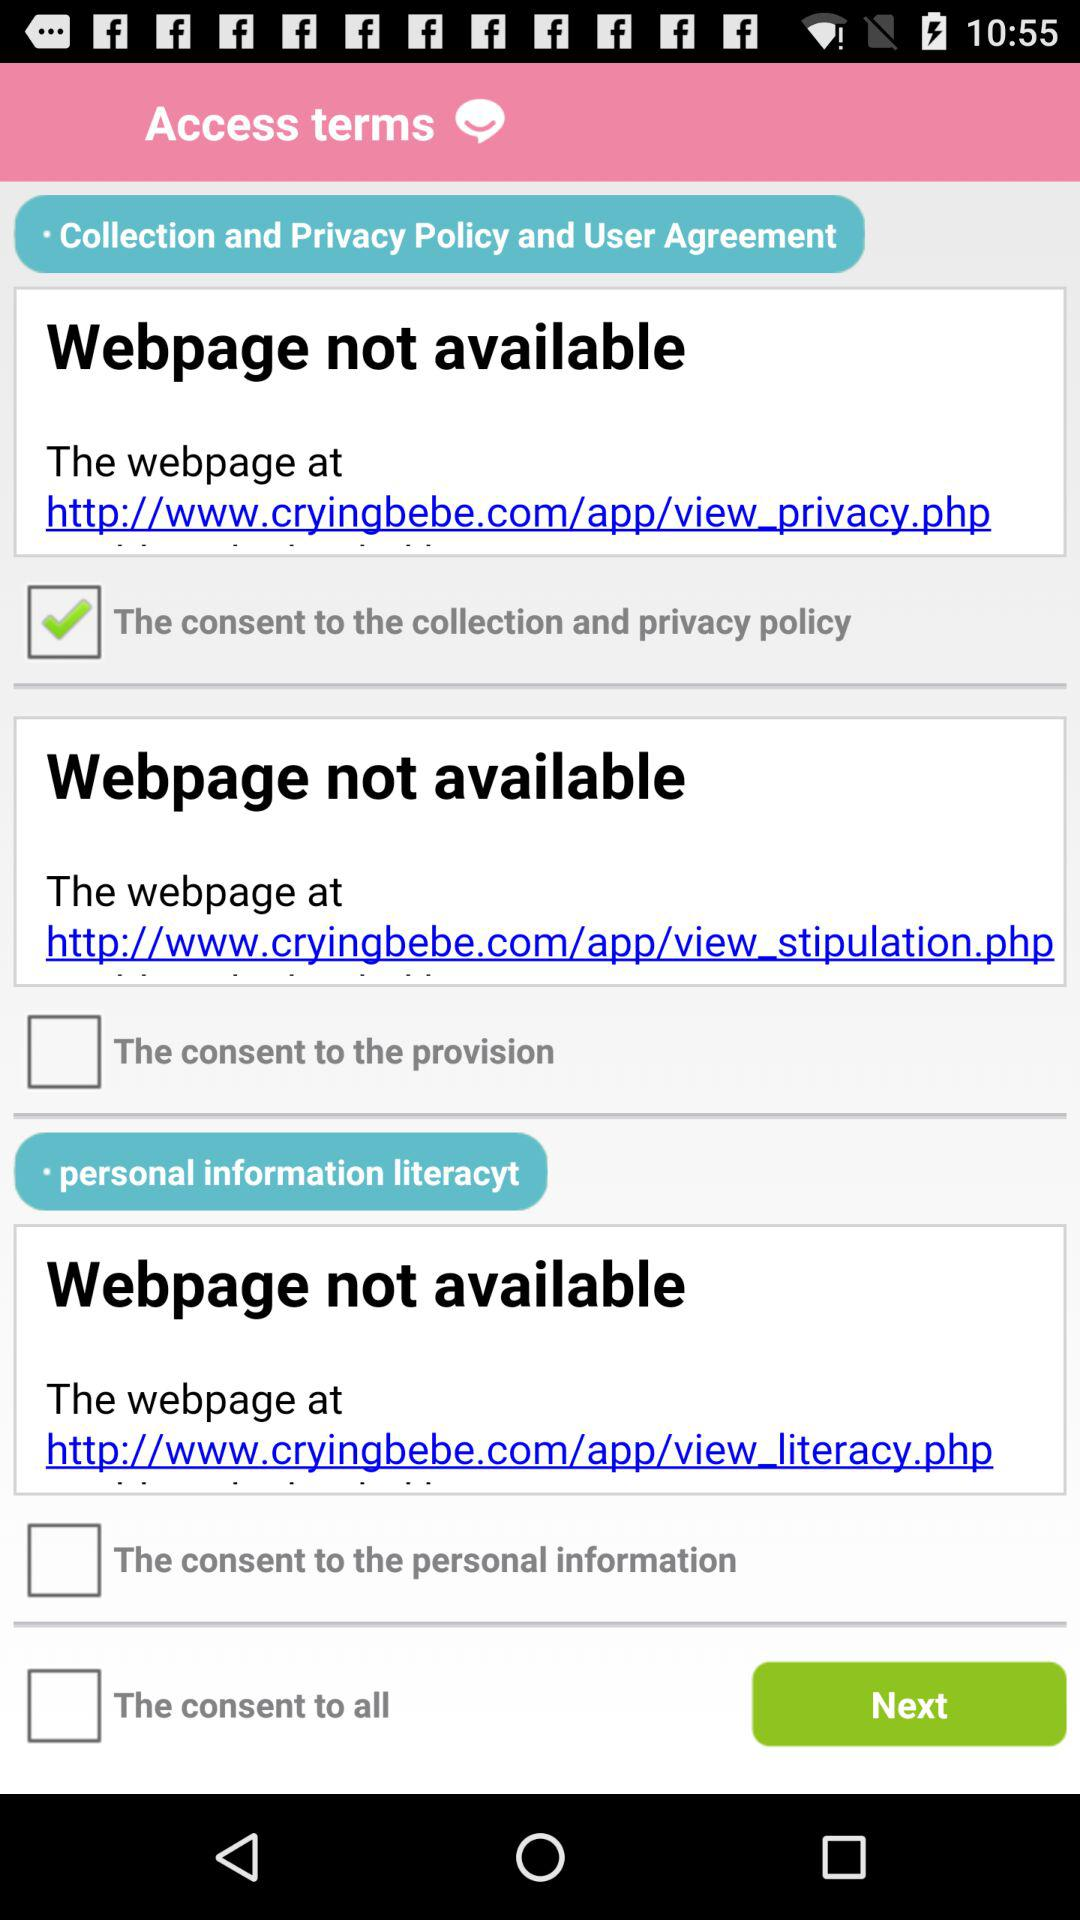What's the status of access terms?
When the provided information is insufficient, respond with <no answer>. <no answer> 